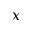Convert formula to latex. <formula><loc_0><loc_0><loc_500><loc_500>x</formula> 